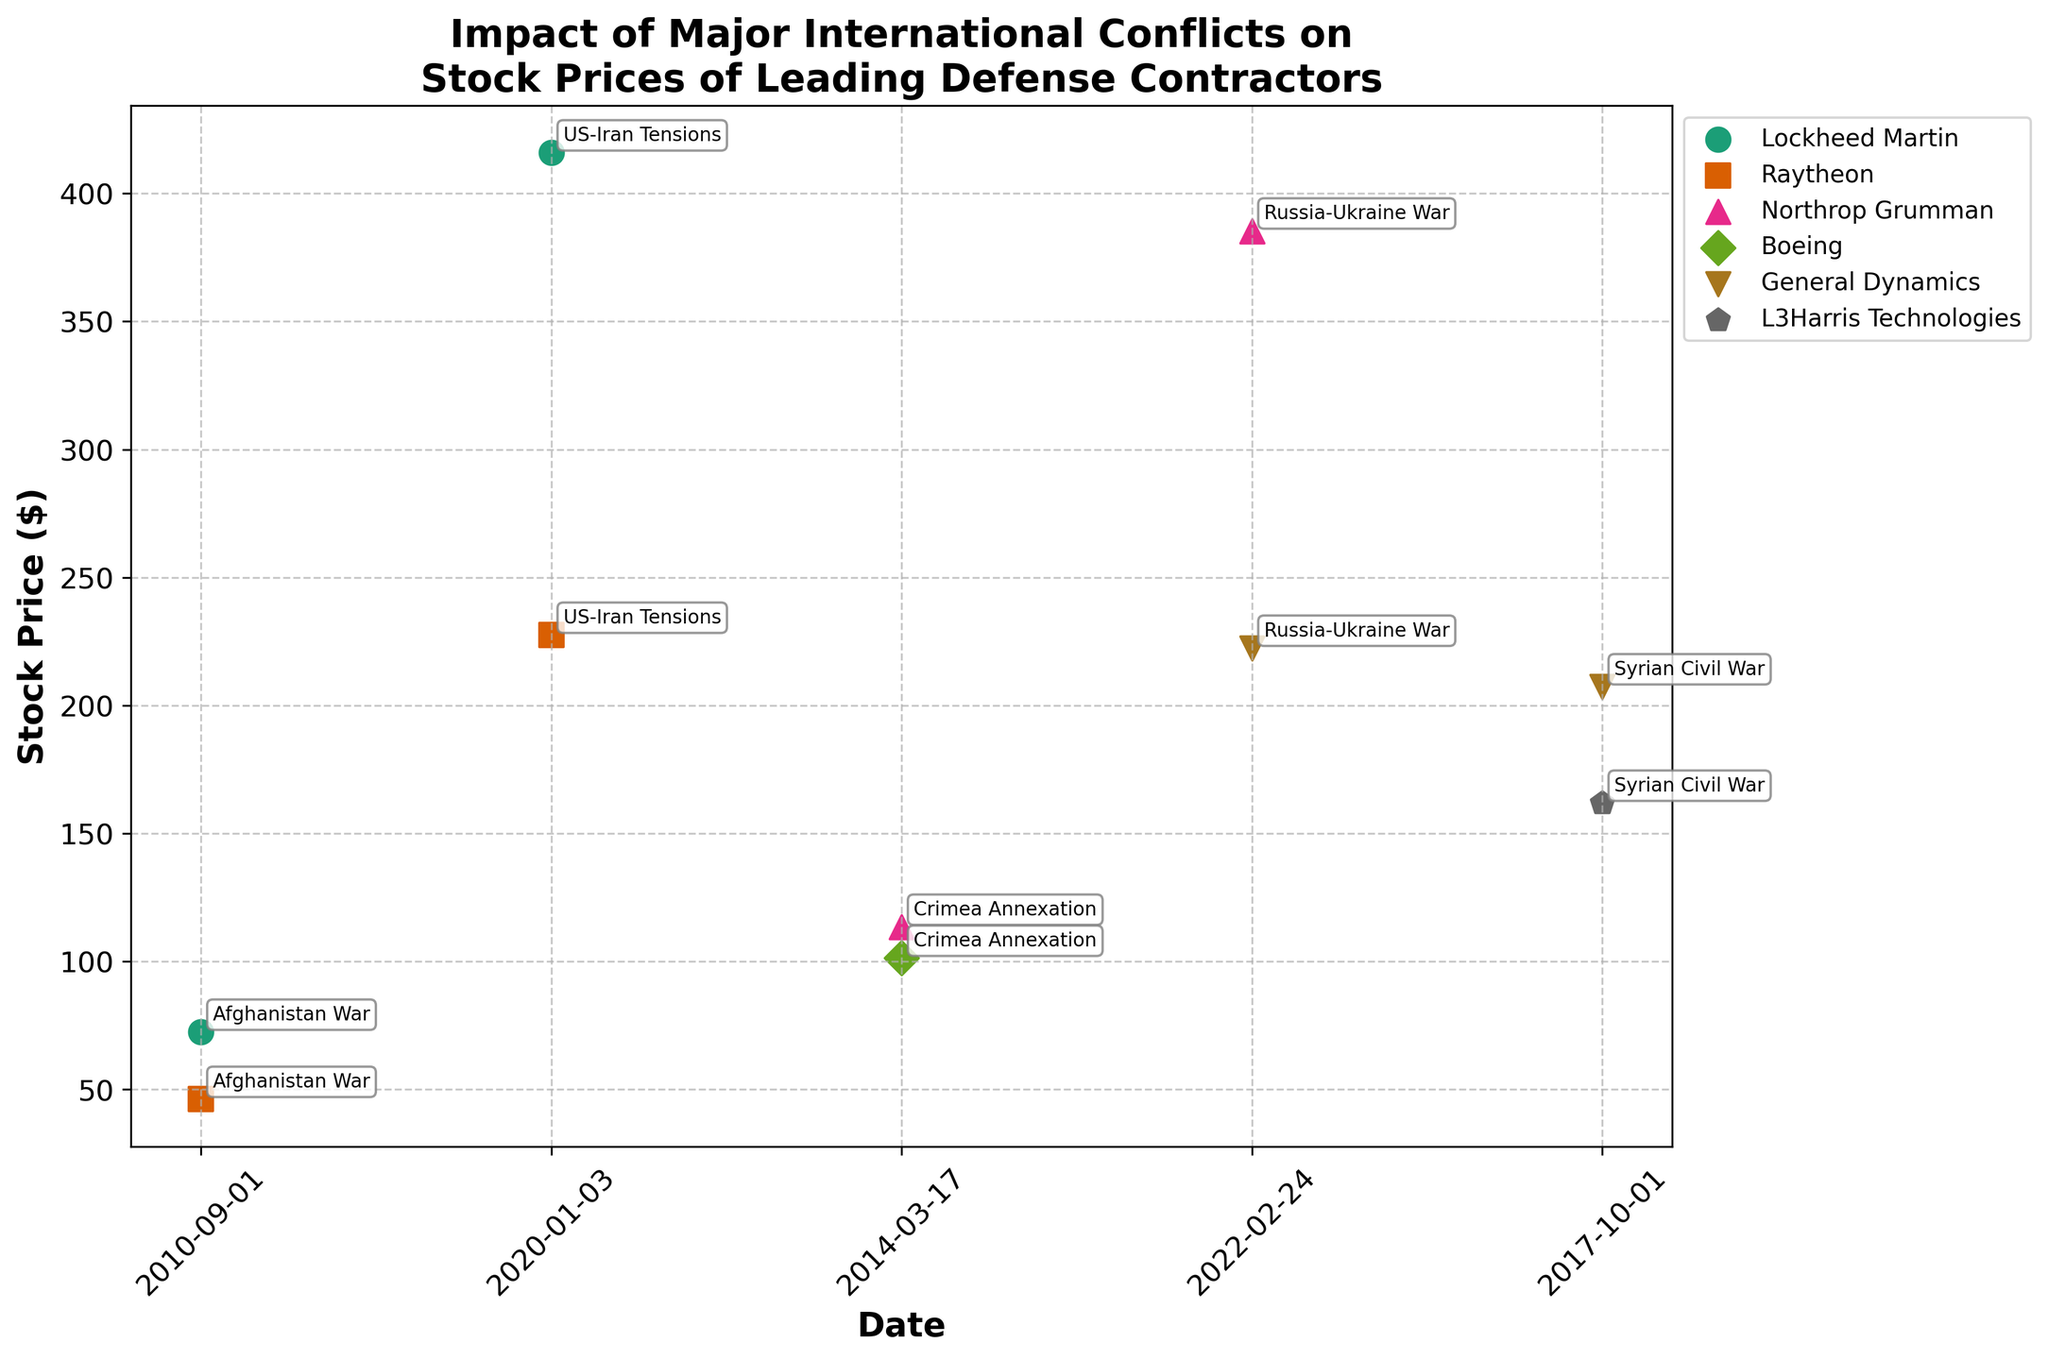what is the latest date represented in the figure? The latest date can be found by looking at the right-most data points on the x-axis, which correspond to the dates. This value is labeled above the stock price points.
Answer: 2022-02-24 Which company had the highest stock price during the Syrian Civil War? To find this, locate the data points associated with the Syrian Civil War and compare the stock prices of the companies involved.
Answer: General Dynamics Compare Lockheed Martin's stock price at the start of the Afghanistan War and during the US-Iran Tensions. Did it increase or decrease? Find the data point for Lockheed Martin's stock price at the start of the Afghanistan War and compare it to the stock price during the US-Iran Tensions. The stock price during the US-Iran Tensions is significantly higher than at the start of the Afghanistan War.
Answer: Increase What is the average stock price of Raytheon during the Afghanistan War and US-Iran Tensions? Locate Raytheon's stock prices for both the Afghanistan War and US-Iran Tensions. Add these prices together and then divide by 2. (46.21 + 227.49) / 2 = 136.85
Answer: 136.85 Which conflict is associated with the highest stock price for any company, and what is that price? Find the highest stock price among all the data points and look at the associated conflict annotation.
Answer: US-Iran Tensions, $415.89 How do the stock prices of General Dynamics and L3Harris Technologies compare during the Syrian Civil War? Identify the data points corresponding to the Syrian Civil War for both companies, then compare their stock prices.
Answer: General Dynamics ($207.35) had a higher stock price than L3Harris Technologies ($161.88) Did Northrop Grumman's stock price increase or decrease from the Crimea Annexation to the Russia-Ukraine War? Compare the stock prices of Northrop Grumman during the Crimea Annexation and Russia-Ukraine War. The stock price increased from $113.45 to $385.39.
Answer: Increase What is the most common conflict associated with the data points? Count the occurrences of each conflict listed next to the stock price points. Most conflicts have two data points each.
Answer: Tied 